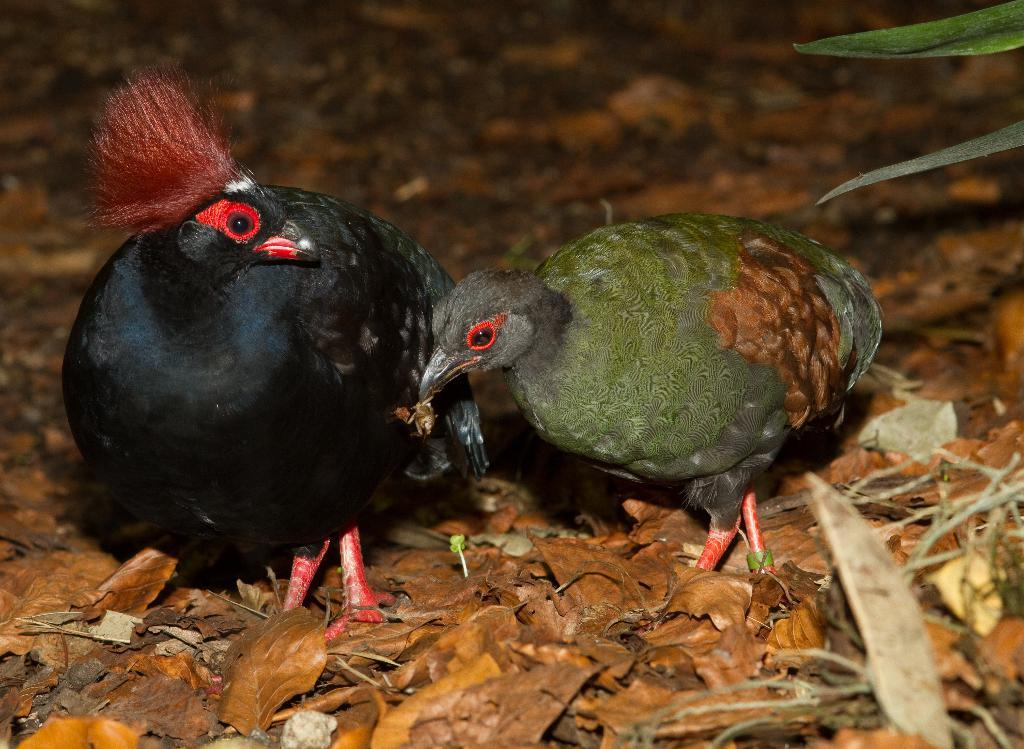What colors are the birds in the image? One bird is black, and the other bird is grey and brown. Where are the birds located in the image? The black bird is on the left side of the image, and the grey and brown bird is on the right side of the image. What can be seen on the floor in the image? There are dried leaves on the floor in the image. Reasoning: Let's think step by step by step in order to produce the conversation. We start by identifying the main subjects in the image, which are the two birds. Then, we describe the colors and locations of the birds based on the provided facts. Finally, we mention the dried leaves on the floor as another detail visible in the image. Absurd Question/Answer: What type of doctor is attending to the sheep in the image? There are no doctors or sheep present in the image; it features two birds and dried leaves on the floor. What type of doctor is attending to the sheep in the image? There are no doctors or sheep present in the image; it features two birds and dried leaves on the floor. 